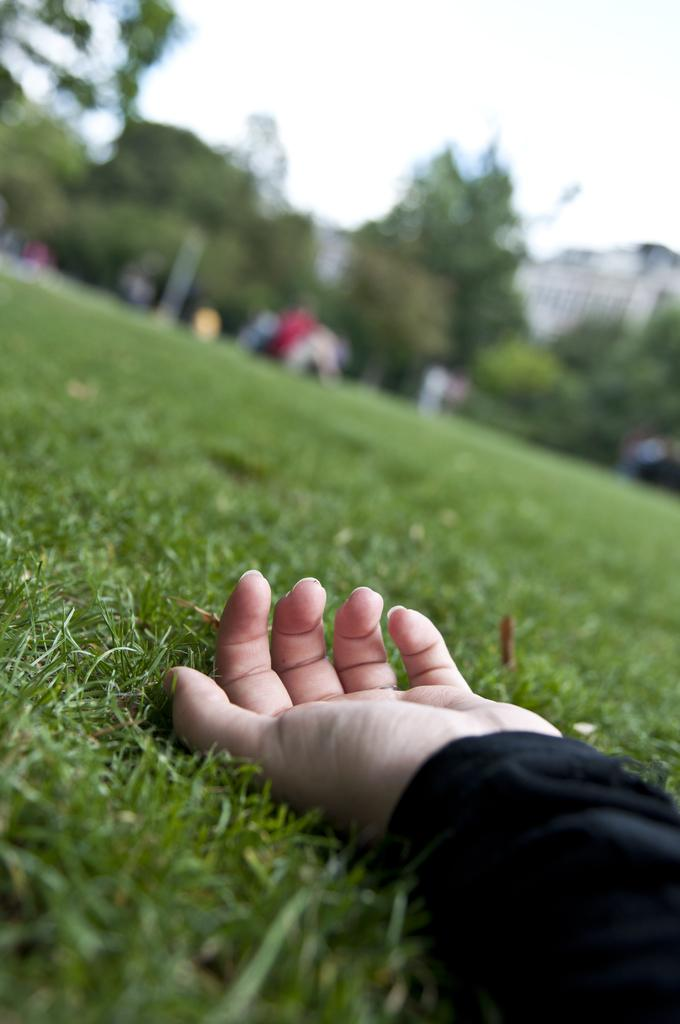What is on the ground in the image? There is a hand on the ground in the image. What can be seen in the background of the image? There are trees and buildings in the background of the image. What type of vegetation is present on the ground in the image? There is grass on the ground in the image. What type of cake is being served on the voyage in the image? There is no voyage or cake present in the image. 